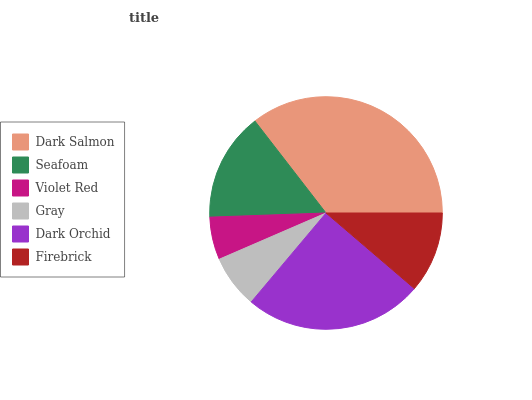Is Violet Red the minimum?
Answer yes or no. Yes. Is Dark Salmon the maximum?
Answer yes or no. Yes. Is Seafoam the minimum?
Answer yes or no. No. Is Seafoam the maximum?
Answer yes or no. No. Is Dark Salmon greater than Seafoam?
Answer yes or no. Yes. Is Seafoam less than Dark Salmon?
Answer yes or no. Yes. Is Seafoam greater than Dark Salmon?
Answer yes or no. No. Is Dark Salmon less than Seafoam?
Answer yes or no. No. Is Seafoam the high median?
Answer yes or no. Yes. Is Firebrick the low median?
Answer yes or no. Yes. Is Gray the high median?
Answer yes or no. No. Is Seafoam the low median?
Answer yes or no. No. 